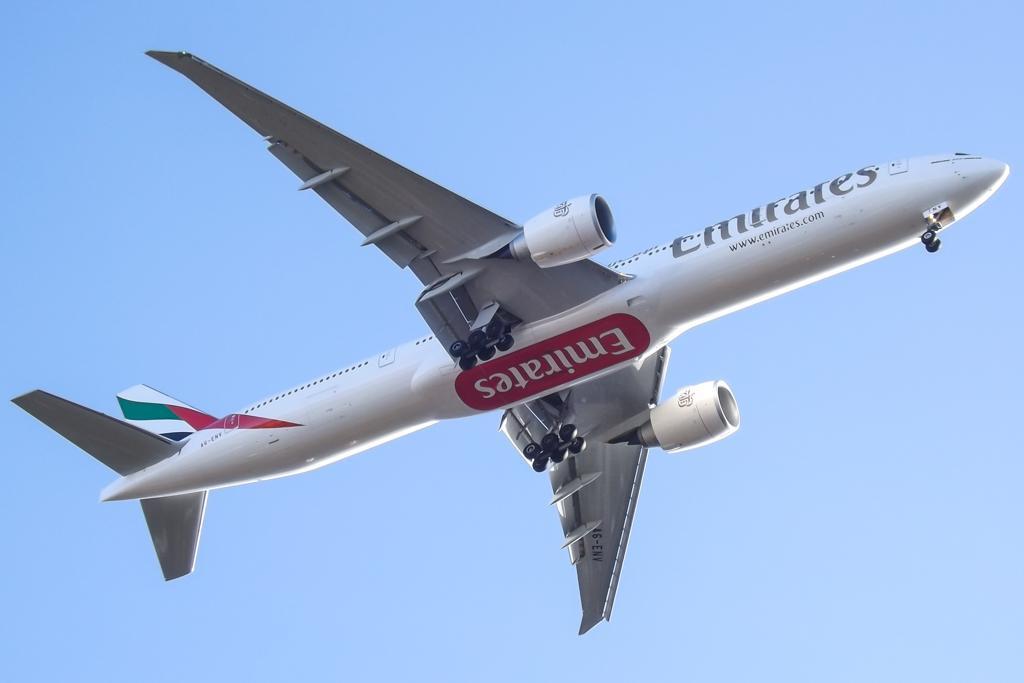Can you describe this image briefly? In this image, we can see an airplane on blue background. 